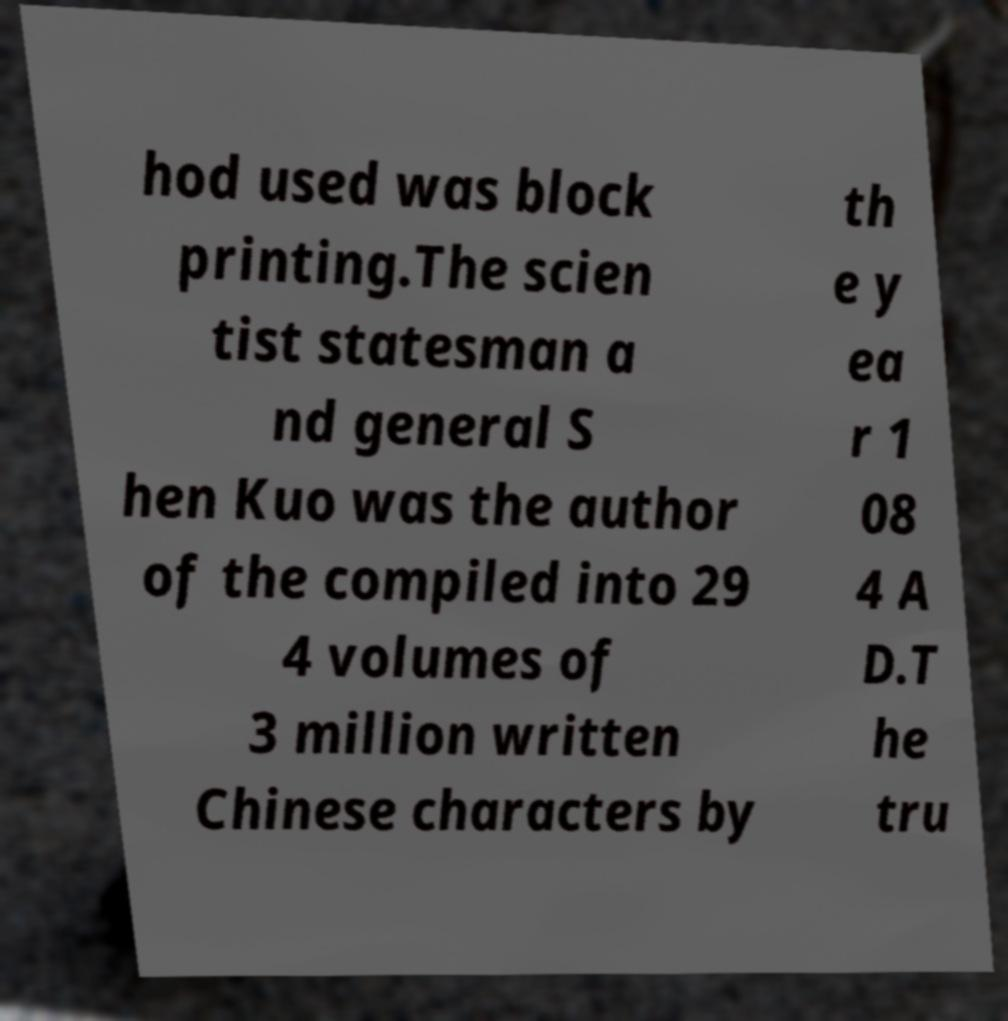Can you read and provide the text displayed in the image?This photo seems to have some interesting text. Can you extract and type it out for me? hod used was block printing.The scien tist statesman a nd general S hen Kuo was the author of the compiled into 29 4 volumes of 3 million written Chinese characters by th e y ea r 1 08 4 A D.T he tru 